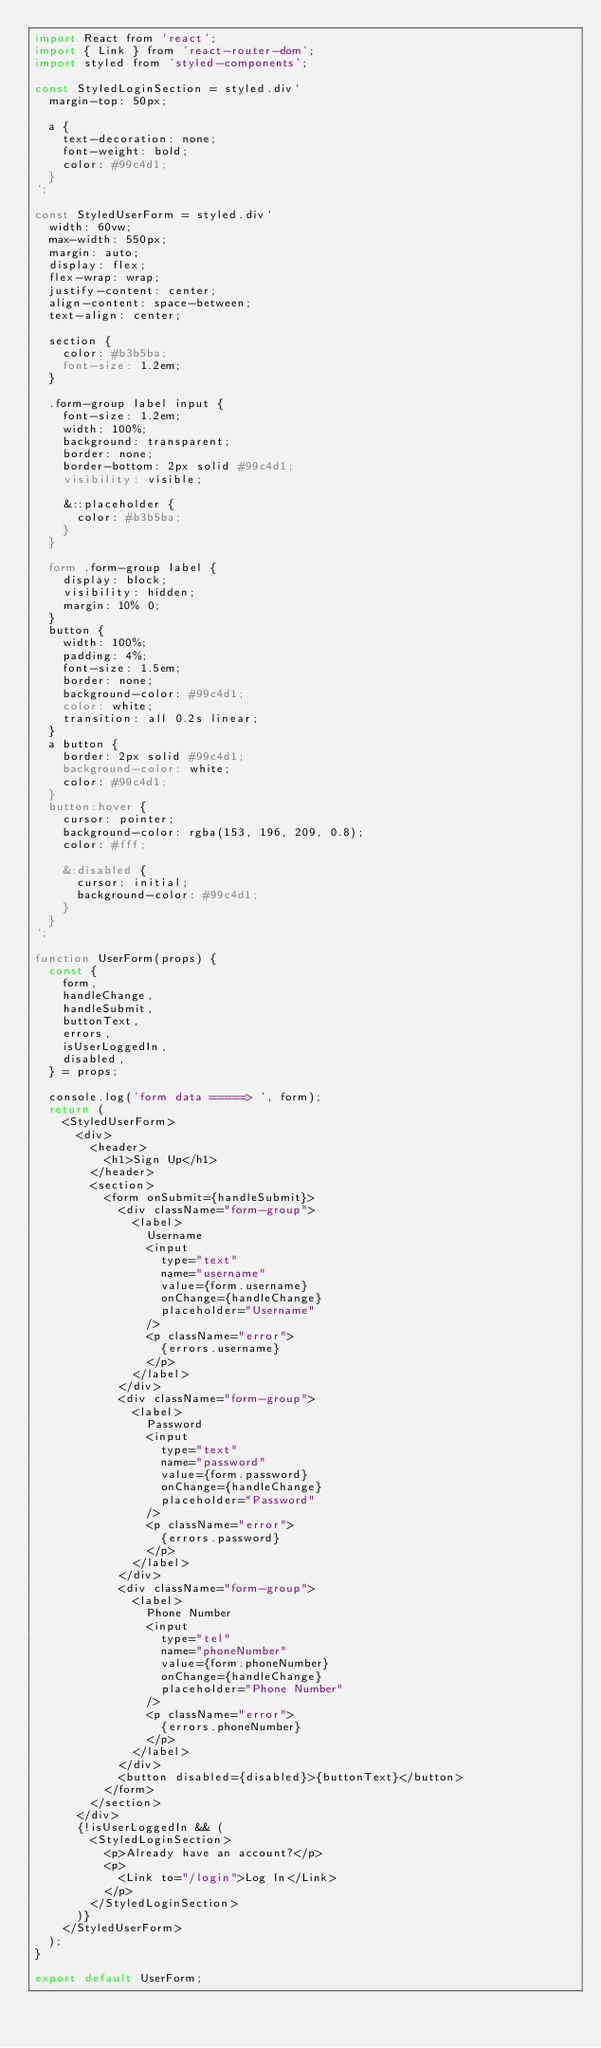Convert code to text. <code><loc_0><loc_0><loc_500><loc_500><_JavaScript_>import React from 'react';
import { Link } from 'react-router-dom';
import styled from 'styled-components';

const StyledLoginSection = styled.div`
	margin-top: 50px;

	a {
		text-decoration: none;
		font-weight: bold;
		color: #99c4d1;
	}
`;

const StyledUserForm = styled.div`
	width: 60vw;
	max-width: 550px;
	margin: auto;
	display: flex;
	flex-wrap: wrap;
	justify-content: center;
	align-content: space-between;
	text-align: center;

	section {
		color: #b3b5ba;
		font-size: 1.2em;
	}

	.form-group label input {
		font-size: 1.2em;
		width: 100%;
		background: transparent;
		border: none;
		border-bottom: 2px solid #99c4d1;
		visibility: visible;

		&::placeholder {
			color: #b3b5ba;
		}
	}

	form .form-group label {
		display: block;
		visibility: hidden;
		margin: 10% 0;
	}
	button {
		width: 100%;
		padding: 4%;
		font-size: 1.5em;
		border: none;
		background-color: #99c4d1;
		color: white;
		transition: all 0.2s linear;
	}
	a button {
		border: 2px solid #99c4d1;
		background-color: white;
		color: #99c4d1;
	}
	button:hover {
		cursor: pointer;
		background-color: rgba(153, 196, 209, 0.8);
		color: #fff;

		&:disabled {
			cursor: initial;
			background-color: #99c4d1;
		}
	}
`;

function UserForm(props) {
	const {
		form,
		handleChange,
		handleSubmit,
		buttonText,
		errors,
		isUserLoggedIn,
		disabled,
	} = props;

	console.log('form data =====> ', form);
	return (
		<StyledUserForm>
			<div>
				<header>
					<h1>Sign Up</h1>
				</header>
				<section>
					<form onSubmit={handleSubmit}>
						<div className="form-group">
							<label>
								Username
								<input
									type="text"
									name="username"
									value={form.username}
									onChange={handleChange}
									placeholder="Username"
								/>
								<p className="error">
									{errors.username}
								</p>
							</label>
						</div>
						<div className="form-group">
							<label>
								Password
								<input
									type="text"
									name="password"
									value={form.password}
									onChange={handleChange}
									placeholder="Password"
								/>
								<p className="error">
									{errors.password}
								</p>
							</label>
						</div>
						<div className="form-group">
							<label>
								Phone Number
								<input
									type="tel"
									name="phoneNumber"
									value={form.phoneNumber}
									onChange={handleChange}
									placeholder="Phone Number"
								/>
								<p className="error">
									{errors.phoneNumber}
								</p>
							</label>
						</div>
						<button disabled={disabled}>{buttonText}</button>
					</form>
				</section>
			</div>
			{!isUserLoggedIn && (
				<StyledLoginSection>
					<p>Already have an account?</p>
					<p>
						<Link to="/login">Log In</Link>
					</p>
				</StyledLoginSection>
			)}
		</StyledUserForm>
	);
}

export default UserForm;
</code> 